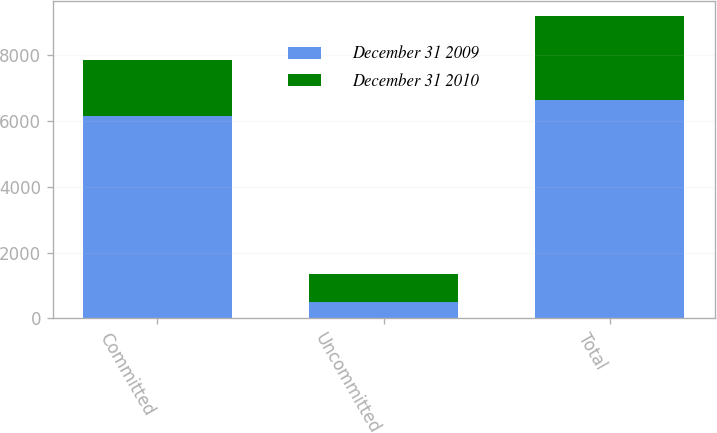Convert chart to OTSL. <chart><loc_0><loc_0><loc_500><loc_500><stacked_bar_chart><ecel><fcel>Committed<fcel>Uncommitted<fcel>Total<nl><fcel>December 31 2009<fcel>6142<fcel>490<fcel>6632<nl><fcel>December 31 2010<fcel>1712<fcel>842<fcel>2554<nl></chart> 